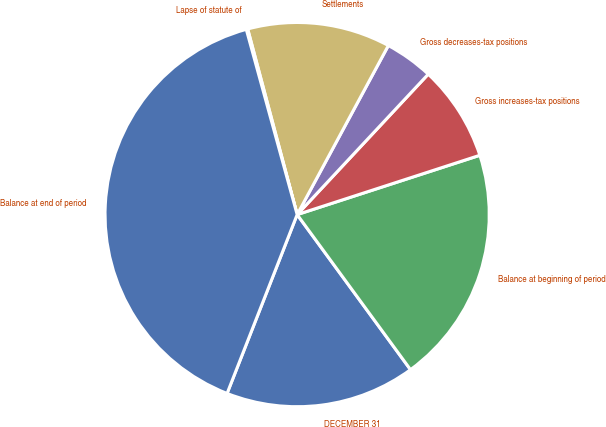Convert chart to OTSL. <chart><loc_0><loc_0><loc_500><loc_500><pie_chart><fcel>DECEMBER 31<fcel>Balance at beginning of period<fcel>Gross increases-tax positions<fcel>Gross decreases-tax positions<fcel>Settlements<fcel>Lapse of statute of<fcel>Balance at end of period<nl><fcel>15.99%<fcel>19.95%<fcel>8.05%<fcel>4.08%<fcel>12.02%<fcel>0.12%<fcel>39.79%<nl></chart> 